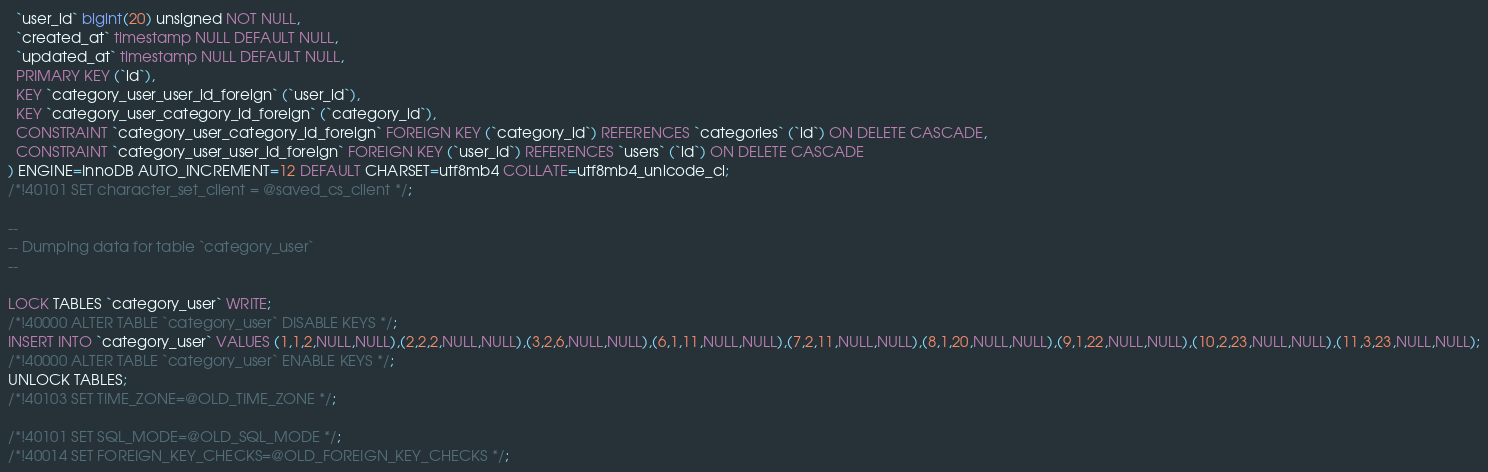Convert code to text. <code><loc_0><loc_0><loc_500><loc_500><_SQL_>  `user_id` bigint(20) unsigned NOT NULL,
  `created_at` timestamp NULL DEFAULT NULL,
  `updated_at` timestamp NULL DEFAULT NULL,
  PRIMARY KEY (`id`),
  KEY `category_user_user_id_foreign` (`user_id`),
  KEY `category_user_category_id_foreign` (`category_id`),
  CONSTRAINT `category_user_category_id_foreign` FOREIGN KEY (`category_id`) REFERENCES `categories` (`id`) ON DELETE CASCADE,
  CONSTRAINT `category_user_user_id_foreign` FOREIGN KEY (`user_id`) REFERENCES `users` (`id`) ON DELETE CASCADE
) ENGINE=InnoDB AUTO_INCREMENT=12 DEFAULT CHARSET=utf8mb4 COLLATE=utf8mb4_unicode_ci;
/*!40101 SET character_set_client = @saved_cs_client */;

--
-- Dumping data for table `category_user`
--

LOCK TABLES `category_user` WRITE;
/*!40000 ALTER TABLE `category_user` DISABLE KEYS */;
INSERT INTO `category_user` VALUES (1,1,2,NULL,NULL),(2,2,2,NULL,NULL),(3,2,6,NULL,NULL),(6,1,11,NULL,NULL),(7,2,11,NULL,NULL),(8,1,20,NULL,NULL),(9,1,22,NULL,NULL),(10,2,23,NULL,NULL),(11,3,23,NULL,NULL);
/*!40000 ALTER TABLE `category_user` ENABLE KEYS */;
UNLOCK TABLES;
/*!40103 SET TIME_ZONE=@OLD_TIME_ZONE */;

/*!40101 SET SQL_MODE=@OLD_SQL_MODE */;
/*!40014 SET FOREIGN_KEY_CHECKS=@OLD_FOREIGN_KEY_CHECKS */;</code> 